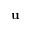<formula> <loc_0><loc_0><loc_500><loc_500>u</formula> 